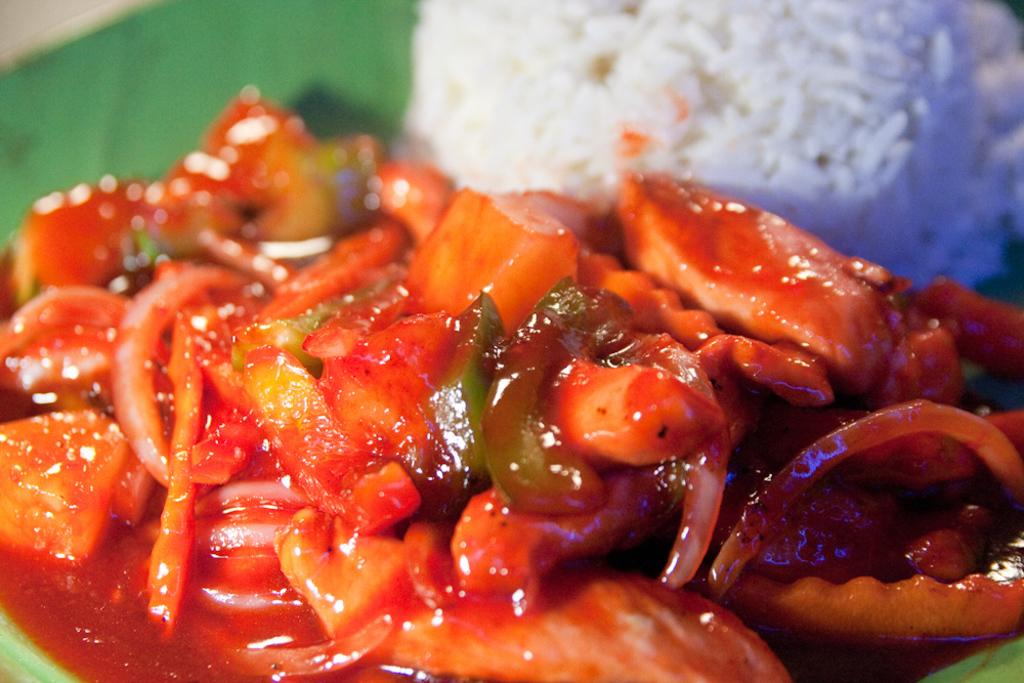What type of food is visible in the image? There is curry and rice in the image. Can you describe the two main components of the dish? The curry is a flavorful sauce or gravy, while the rice is a starchy, grain-based side dish. What type of note is being played by the mice in the image? There are no mice or musical notes present in the image; it only features curry and rice. 